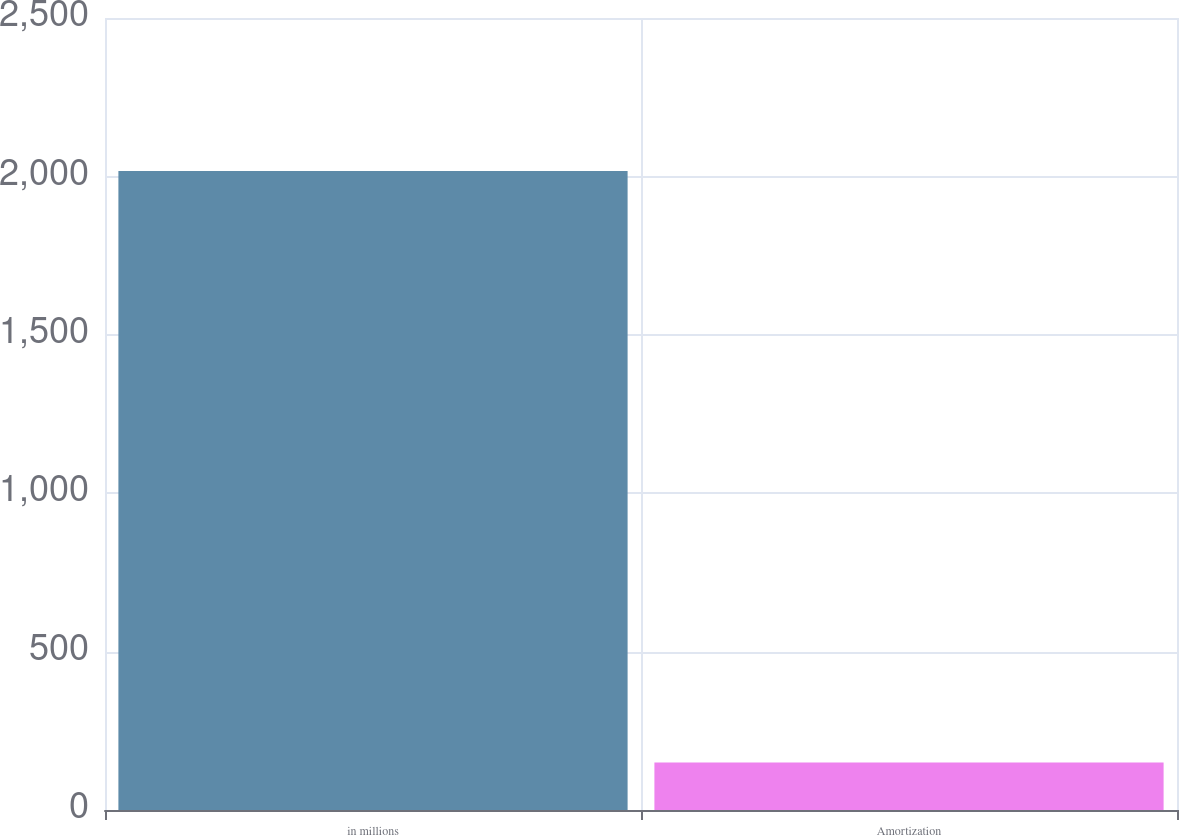Convert chart. <chart><loc_0><loc_0><loc_500><loc_500><bar_chart><fcel>in millions<fcel>Amortization<nl><fcel>2017<fcel>150<nl></chart> 